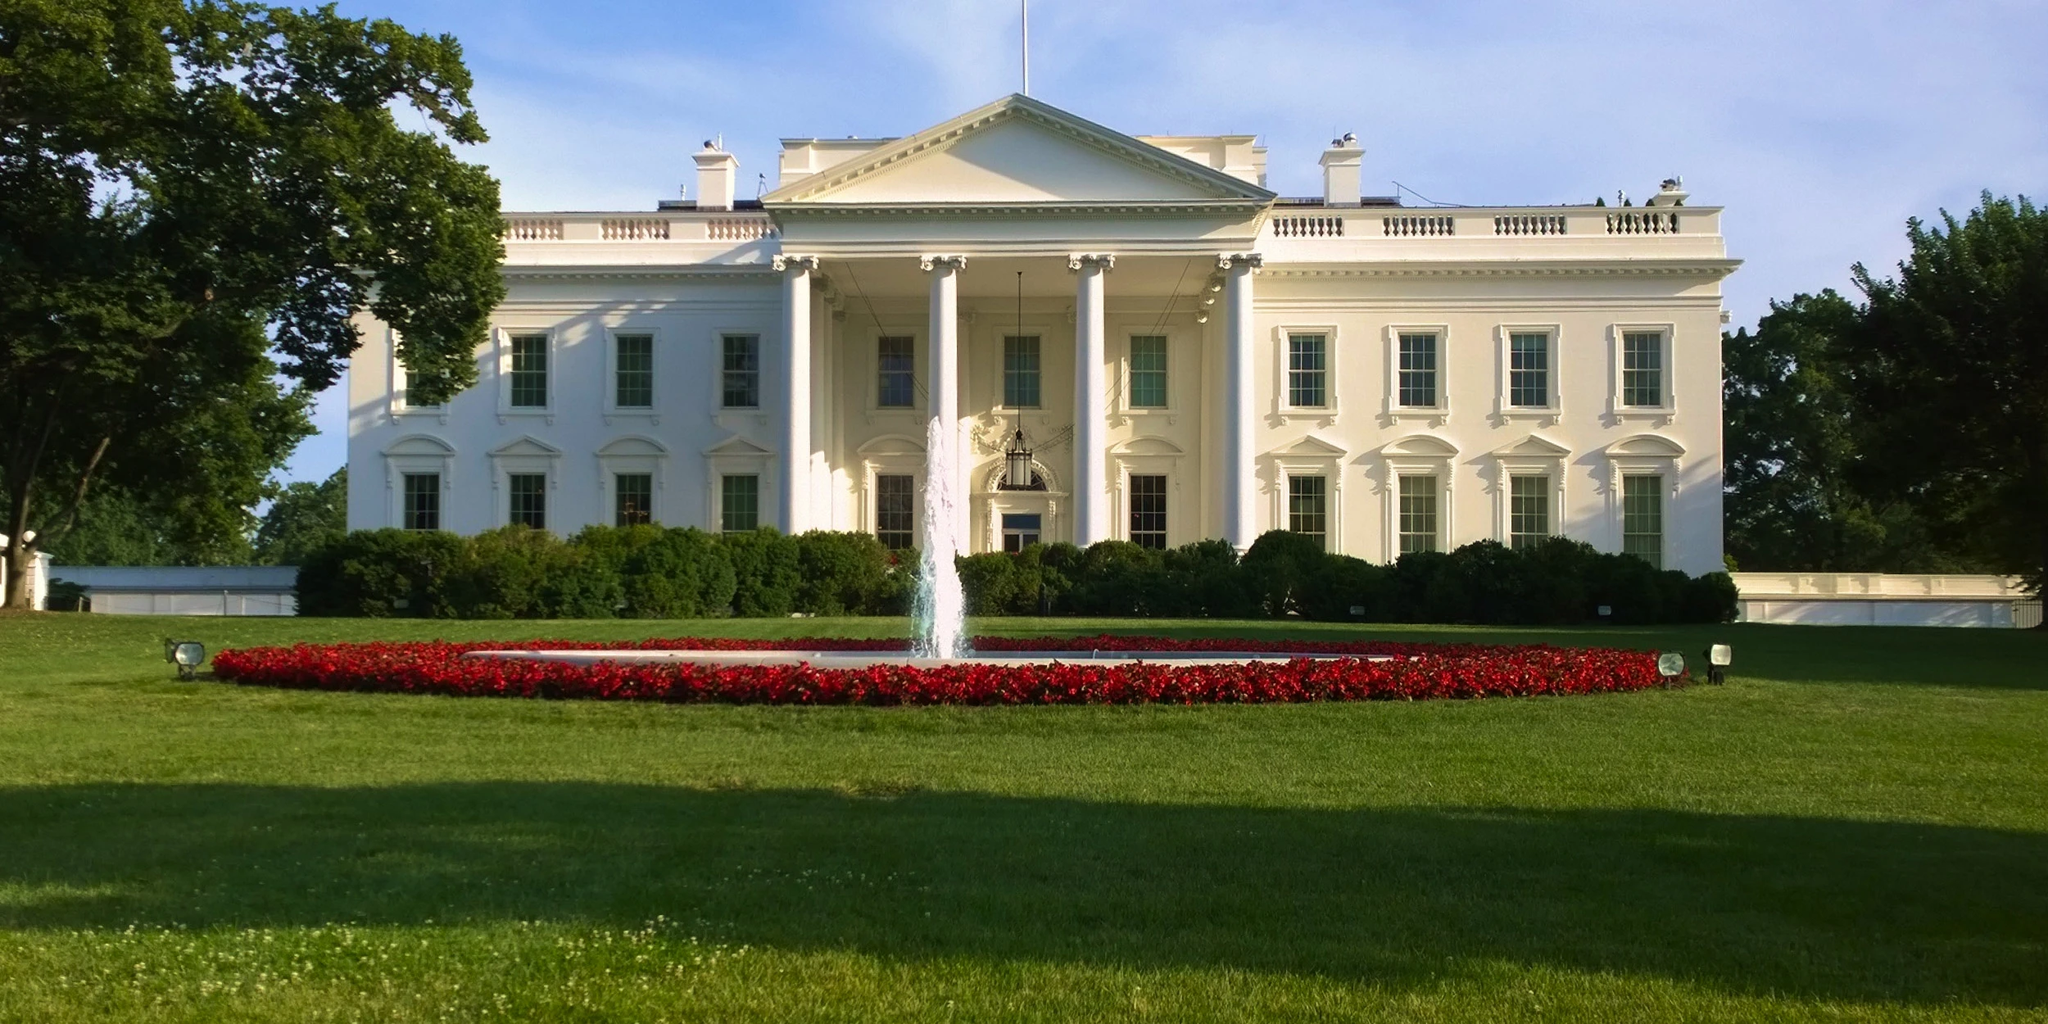What is this photo about? The image depicts the White House, a powerful symbol of the U.S. presidency and a key piece of American political history. The building's neoclassical architecture, featuring prominent columns and a stately portico, is painted in its traditional white. It is set against a backdrop of a clear blue sky, enhancing the grandeur of its facade. The foreground shows the meticulously maintained lawn with a vibrant display of red flowers and a central fountain that adds a peaceful element to the scene. This place, beyond being the president's residence, has witnessed numerous historical events and represents the executive power of the United States government. 